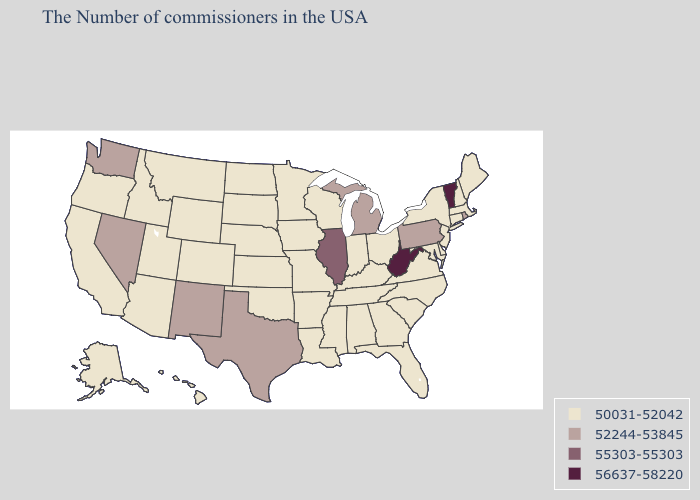What is the value of Kentucky?
Concise answer only. 50031-52042. What is the highest value in the USA?
Write a very short answer. 56637-58220. Name the states that have a value in the range 50031-52042?
Short answer required. Maine, Massachusetts, New Hampshire, Connecticut, New York, New Jersey, Delaware, Maryland, Virginia, North Carolina, South Carolina, Ohio, Florida, Georgia, Kentucky, Indiana, Alabama, Tennessee, Wisconsin, Mississippi, Louisiana, Missouri, Arkansas, Minnesota, Iowa, Kansas, Nebraska, Oklahoma, South Dakota, North Dakota, Wyoming, Colorado, Utah, Montana, Arizona, Idaho, California, Oregon, Alaska, Hawaii. What is the highest value in states that border New Mexico?
Quick response, please. 52244-53845. Does the map have missing data?
Be succinct. No. Does Minnesota have a lower value than Illinois?
Concise answer only. Yes. Which states hav the highest value in the West?
Be succinct. New Mexico, Nevada, Washington. Name the states that have a value in the range 52244-53845?
Short answer required. Rhode Island, Pennsylvania, Michigan, Texas, New Mexico, Nevada, Washington. Does Arkansas have the highest value in the USA?
Keep it brief. No. Name the states that have a value in the range 52244-53845?
Give a very brief answer. Rhode Island, Pennsylvania, Michigan, Texas, New Mexico, Nevada, Washington. Does Utah have the lowest value in the USA?
Give a very brief answer. Yes. Does Pennsylvania have a lower value than Minnesota?
Keep it brief. No. What is the value of Colorado?
Quick response, please. 50031-52042. What is the lowest value in states that border Nebraska?
Short answer required. 50031-52042. Does the map have missing data?
Keep it brief. No. 